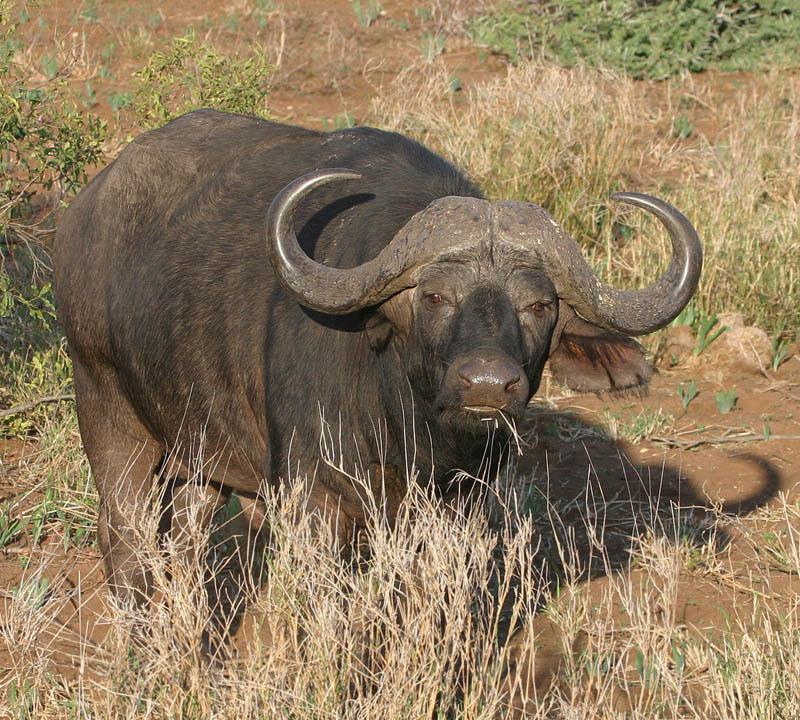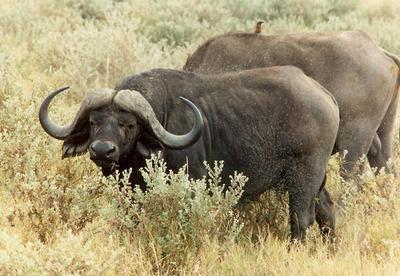The first image is the image on the left, the second image is the image on the right. For the images displayed, is the sentence "Two water buffalos are standing in water." factually correct? Answer yes or no. No. The first image is the image on the left, the second image is the image on the right. Considering the images on both sides, is "An image contains a water buffalo standing in water." valid? Answer yes or no. No. 